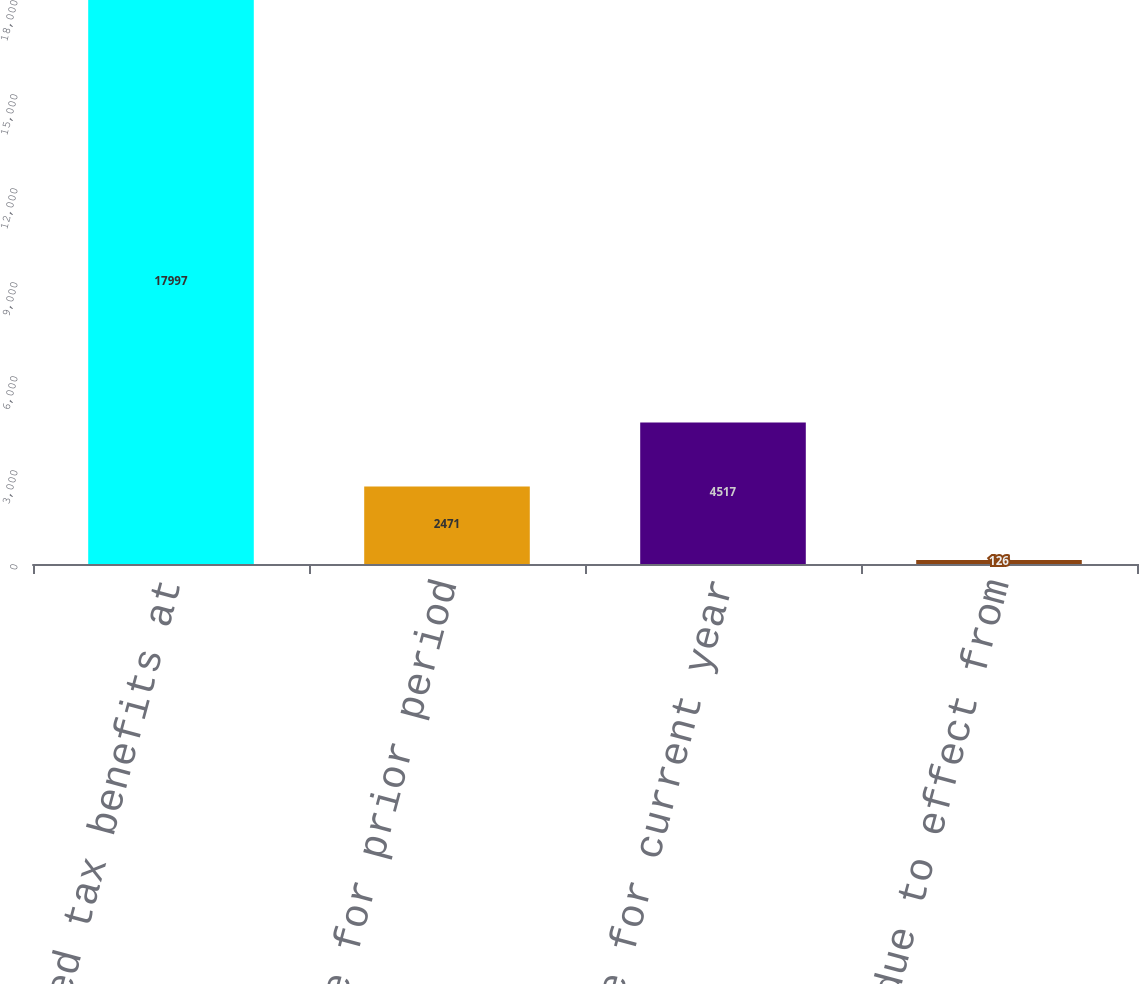Convert chart to OTSL. <chart><loc_0><loc_0><loc_500><loc_500><bar_chart><fcel>Unrecognized tax benefits at<fcel>Gross change for prior period<fcel>Gross change for current year<fcel>Decrease due to effect from<nl><fcel>17997<fcel>2471<fcel>4517<fcel>126<nl></chart> 